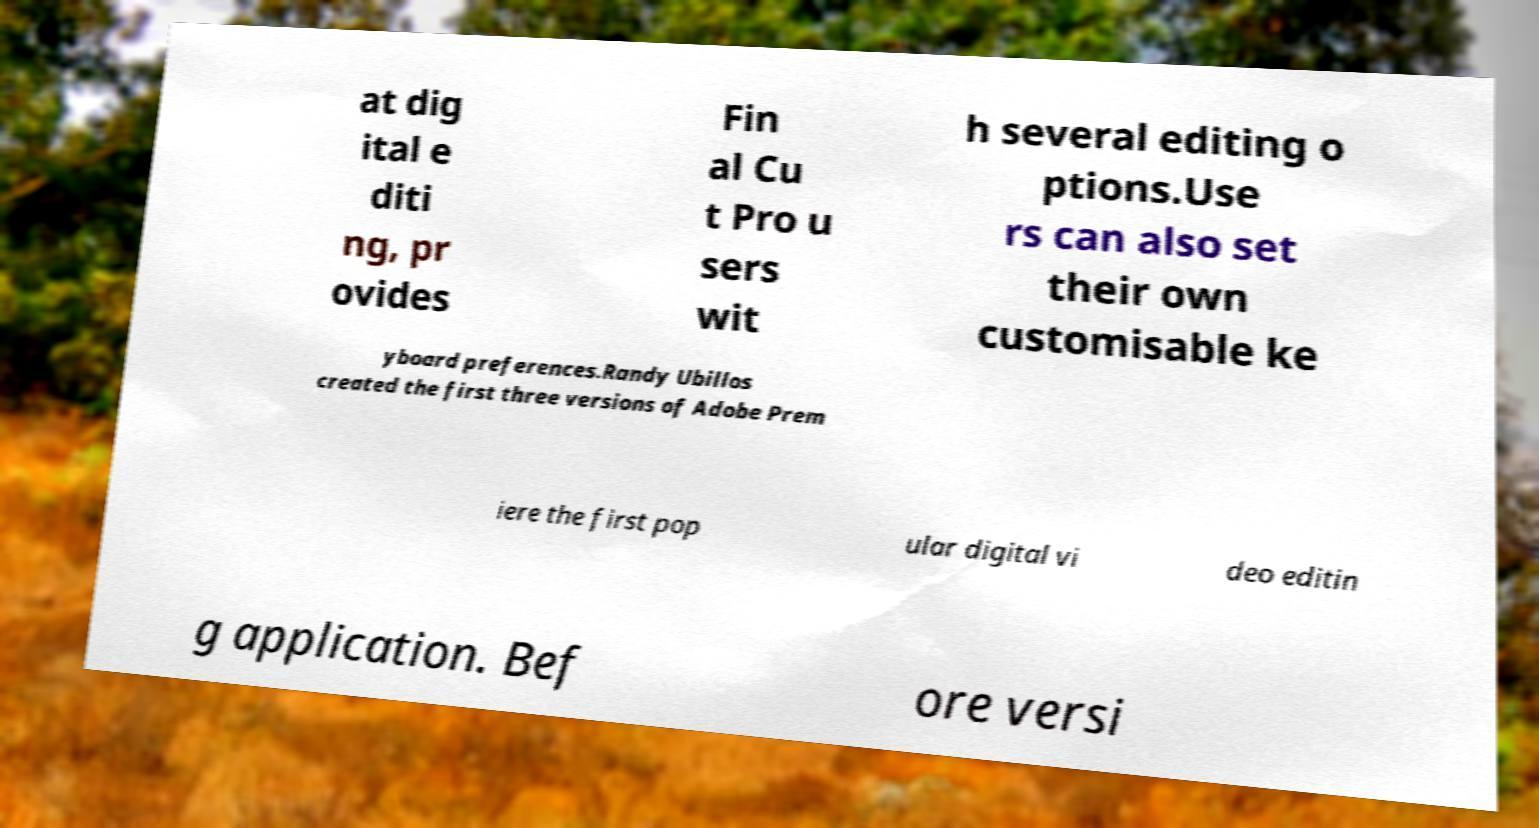Could you assist in decoding the text presented in this image and type it out clearly? at dig ital e diti ng, pr ovides Fin al Cu t Pro u sers wit h several editing o ptions.Use rs can also set their own customisable ke yboard preferences.Randy Ubillos created the first three versions of Adobe Prem iere the first pop ular digital vi deo editin g application. Bef ore versi 